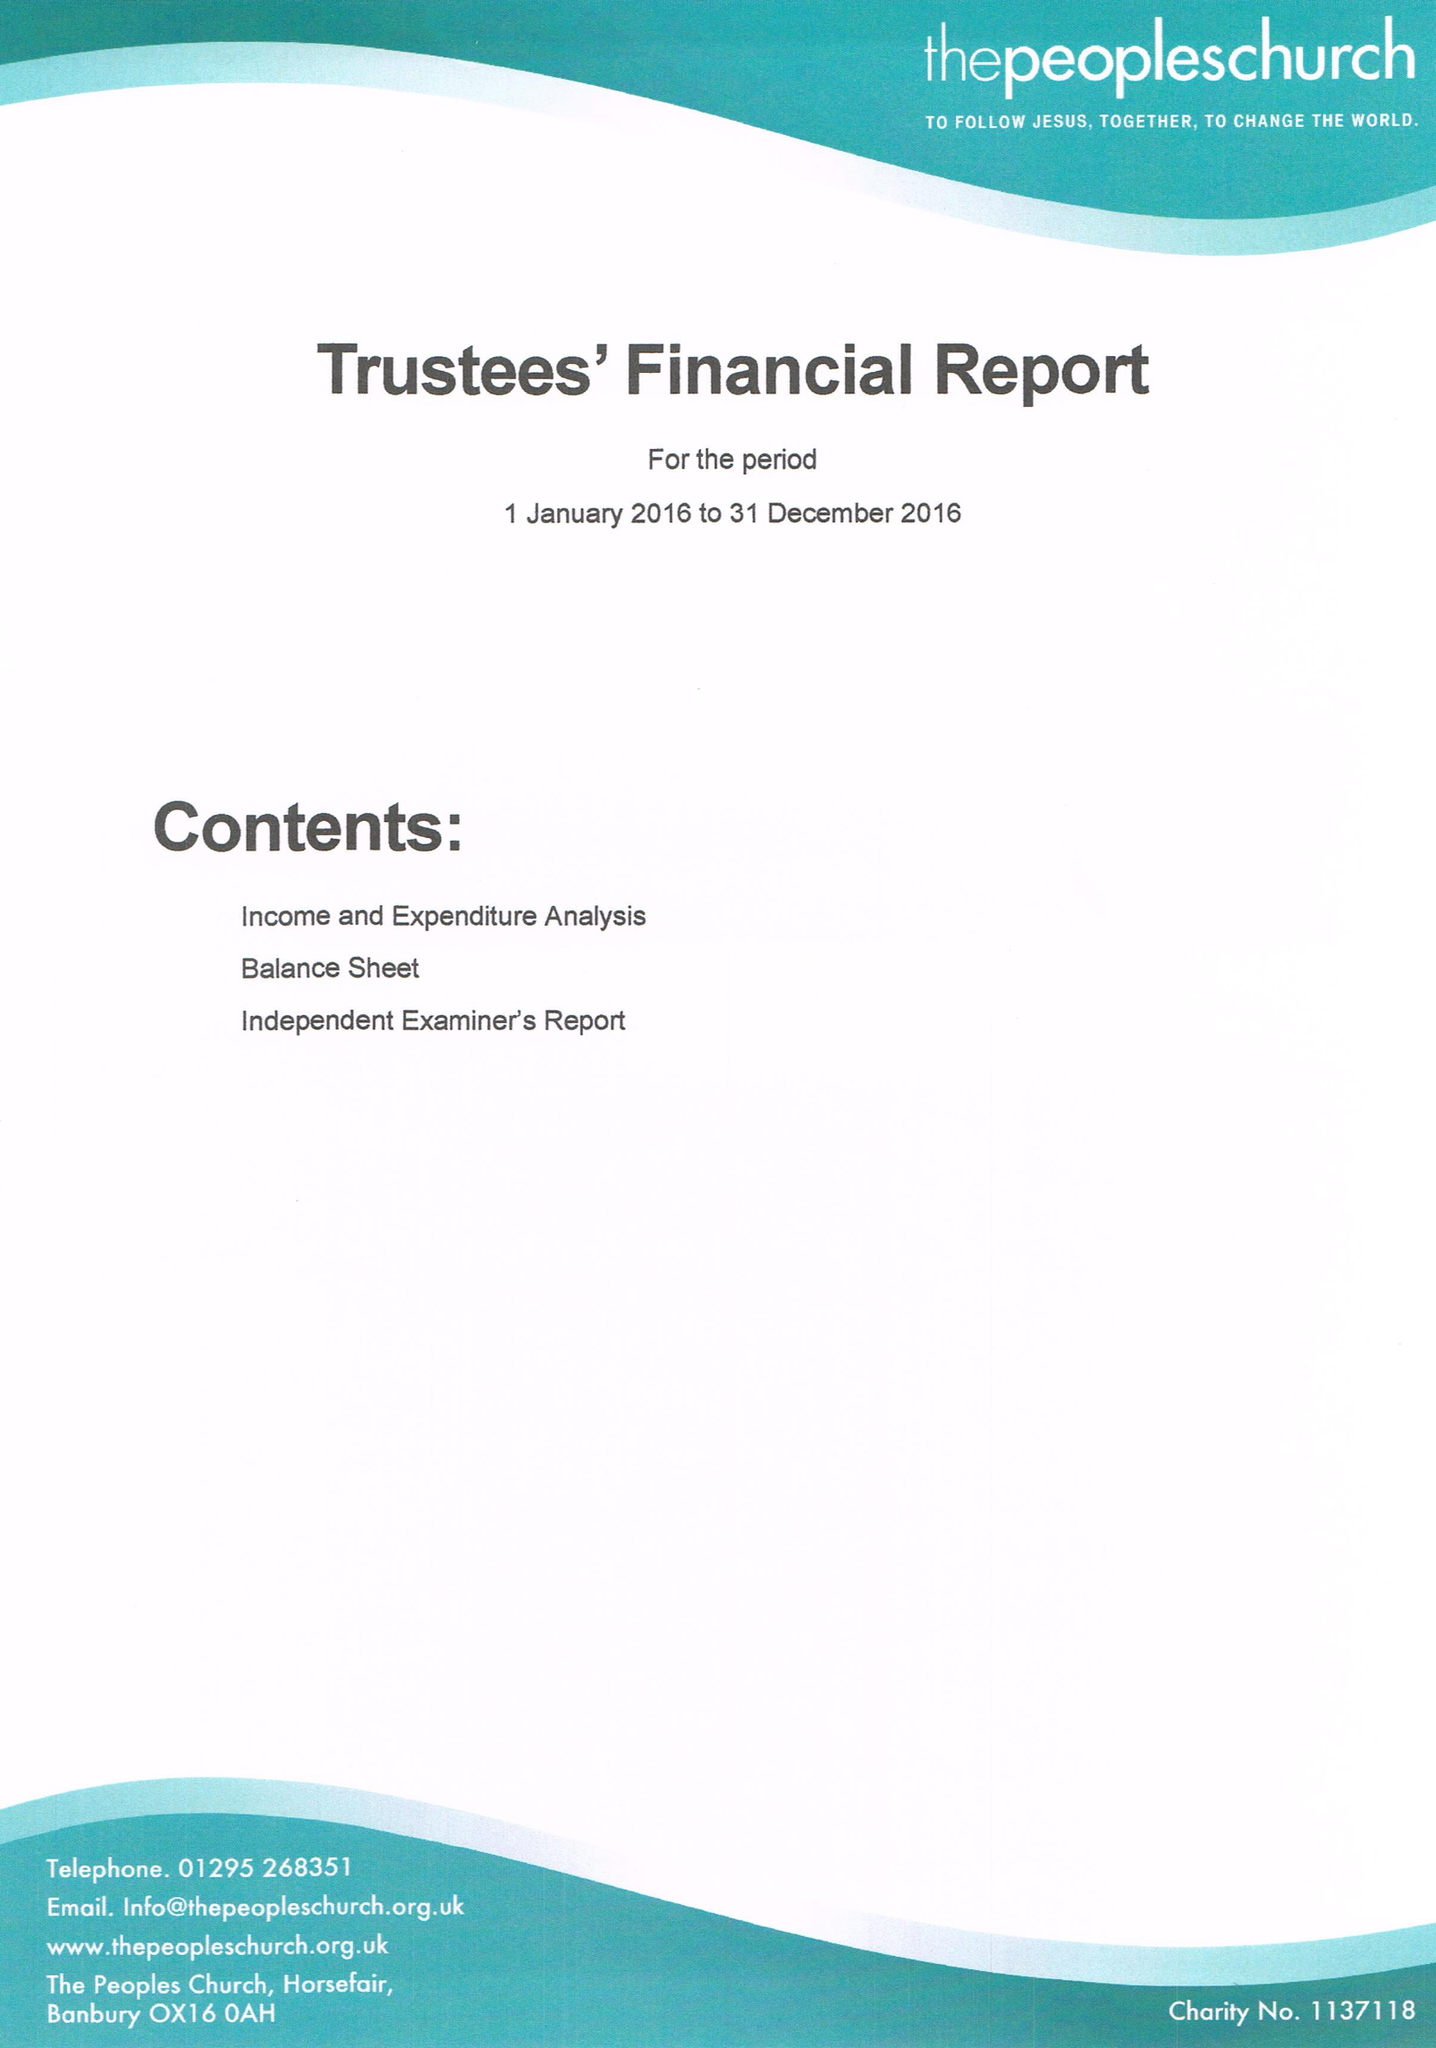What is the value for the address__post_town?
Answer the question using a single word or phrase. BANBURY 